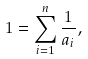Convert formula to latex. <formula><loc_0><loc_0><loc_500><loc_500>1 = \sum _ { i = 1 } ^ { n } \frac { 1 } { a _ { i } } ,</formula> 